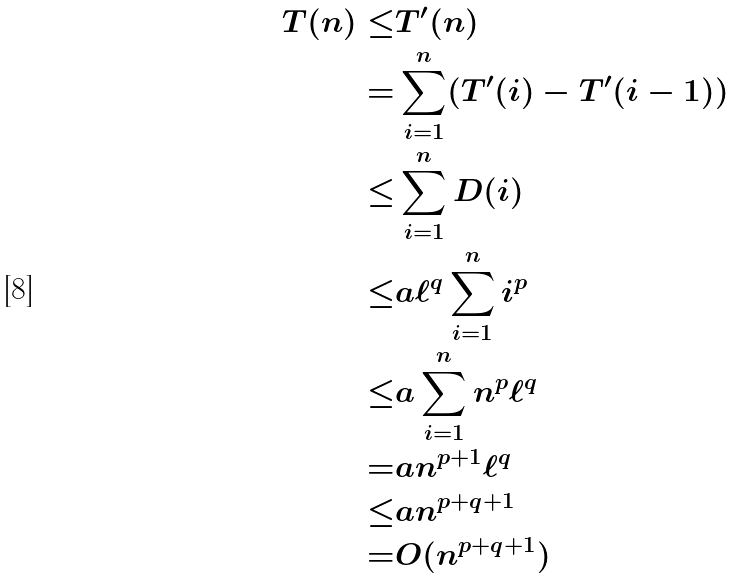Convert formula to latex. <formula><loc_0><loc_0><loc_500><loc_500>T ( n ) \leq & T ^ { \prime } ( n ) \\ = & \sum _ { i = 1 } ^ { n } ( T ^ { \prime } ( i ) - T ^ { \prime } ( i - 1 ) ) \\ \leq & \sum _ { i = 1 } ^ { n } D ( i ) \\ \leq & a \ell ^ { q } \sum _ { i = 1 } ^ { n } i ^ { p } \\ \leq & a \sum _ { i = 1 } ^ { n } n ^ { p } \ell ^ { q } \\ = & a n ^ { p + 1 } \ell ^ { q } \\ \leq & a n ^ { p + q + 1 } \\ = & O ( n ^ { p + q + 1 } )</formula> 